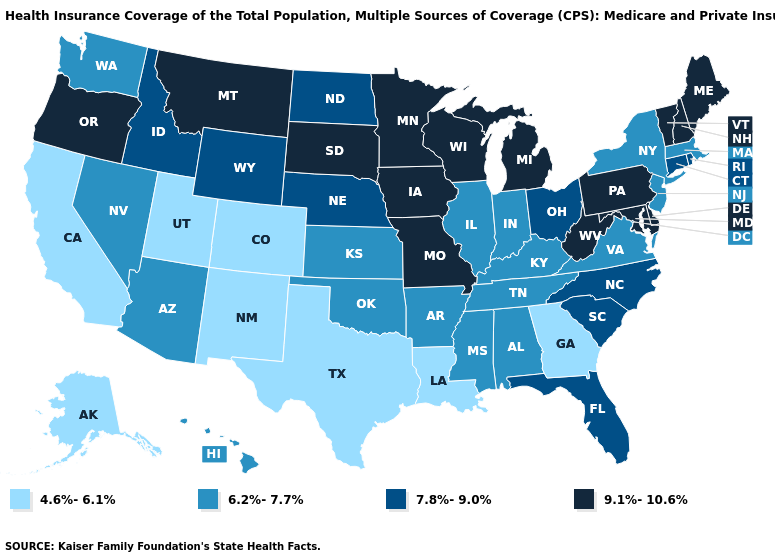What is the value of Ohio?
Concise answer only. 7.8%-9.0%. Name the states that have a value in the range 7.8%-9.0%?
Give a very brief answer. Connecticut, Florida, Idaho, Nebraska, North Carolina, North Dakota, Ohio, Rhode Island, South Carolina, Wyoming. Does Maine have the lowest value in the Northeast?
Answer briefly. No. What is the value of Minnesota?
Concise answer only. 9.1%-10.6%. What is the value of Vermont?
Give a very brief answer. 9.1%-10.6%. What is the highest value in states that border Oklahoma?
Write a very short answer. 9.1%-10.6%. Name the states that have a value in the range 7.8%-9.0%?
Write a very short answer. Connecticut, Florida, Idaho, Nebraska, North Carolina, North Dakota, Ohio, Rhode Island, South Carolina, Wyoming. Among the states that border Idaho , which have the highest value?
Concise answer only. Montana, Oregon. Name the states that have a value in the range 9.1%-10.6%?
Concise answer only. Delaware, Iowa, Maine, Maryland, Michigan, Minnesota, Missouri, Montana, New Hampshire, Oregon, Pennsylvania, South Dakota, Vermont, West Virginia, Wisconsin. Does the map have missing data?
Give a very brief answer. No. Among the states that border Rhode Island , which have the lowest value?
Concise answer only. Massachusetts. What is the highest value in the USA?
Be succinct. 9.1%-10.6%. Which states have the lowest value in the USA?
Keep it brief. Alaska, California, Colorado, Georgia, Louisiana, New Mexico, Texas, Utah. Name the states that have a value in the range 9.1%-10.6%?
Short answer required. Delaware, Iowa, Maine, Maryland, Michigan, Minnesota, Missouri, Montana, New Hampshire, Oregon, Pennsylvania, South Dakota, Vermont, West Virginia, Wisconsin. Does Kentucky have the highest value in the USA?
Keep it brief. No. 